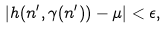<formula> <loc_0><loc_0><loc_500><loc_500>| h ( n ^ { \prime } , \gamma ( n ^ { \prime } ) ) - \mu | < \epsilon ,</formula> 